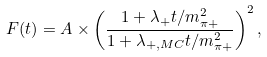<formula> <loc_0><loc_0><loc_500><loc_500>F ( t ) = A \times \left ( \frac { 1 + \lambda _ { + } t / m _ { \pi + } ^ { 2 } } { 1 + \lambda _ { + , M C } t / m _ { \pi + } ^ { 2 } } \right ) ^ { 2 } ,</formula> 